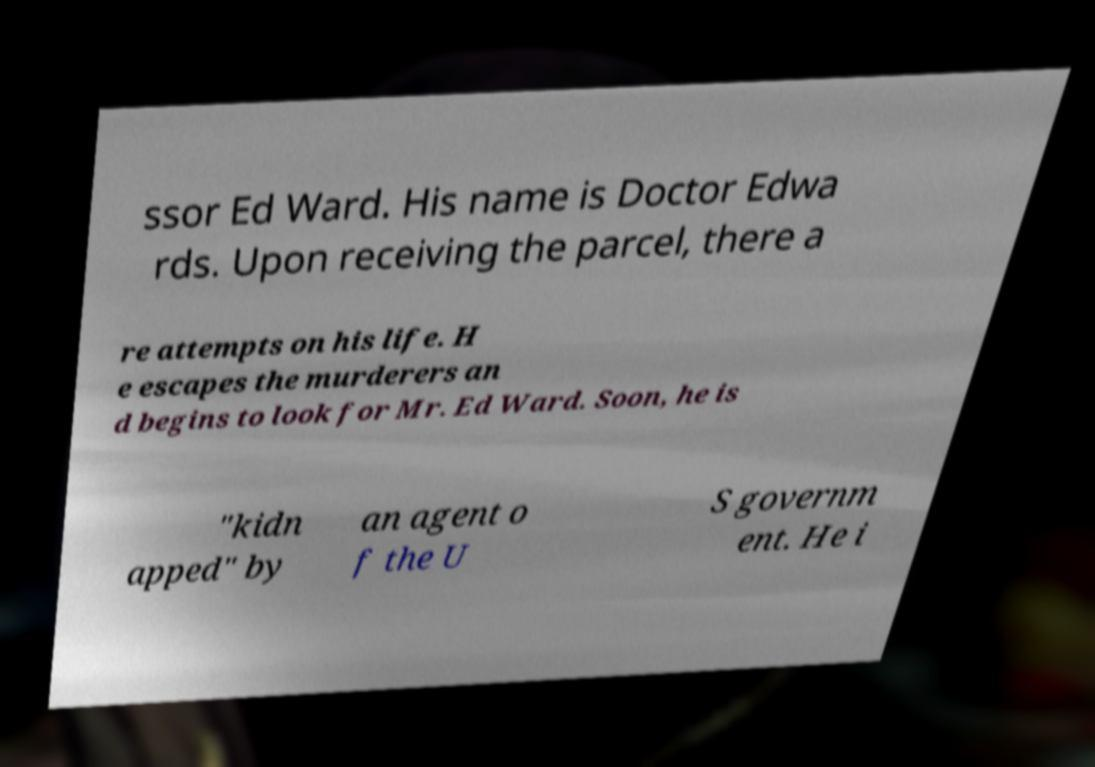For documentation purposes, I need the text within this image transcribed. Could you provide that? ssor Ed Ward. His name is Doctor Edwa rds. Upon receiving the parcel, there a re attempts on his life. H e escapes the murderers an d begins to look for Mr. Ed Ward. Soon, he is "kidn apped" by an agent o f the U S governm ent. He i 